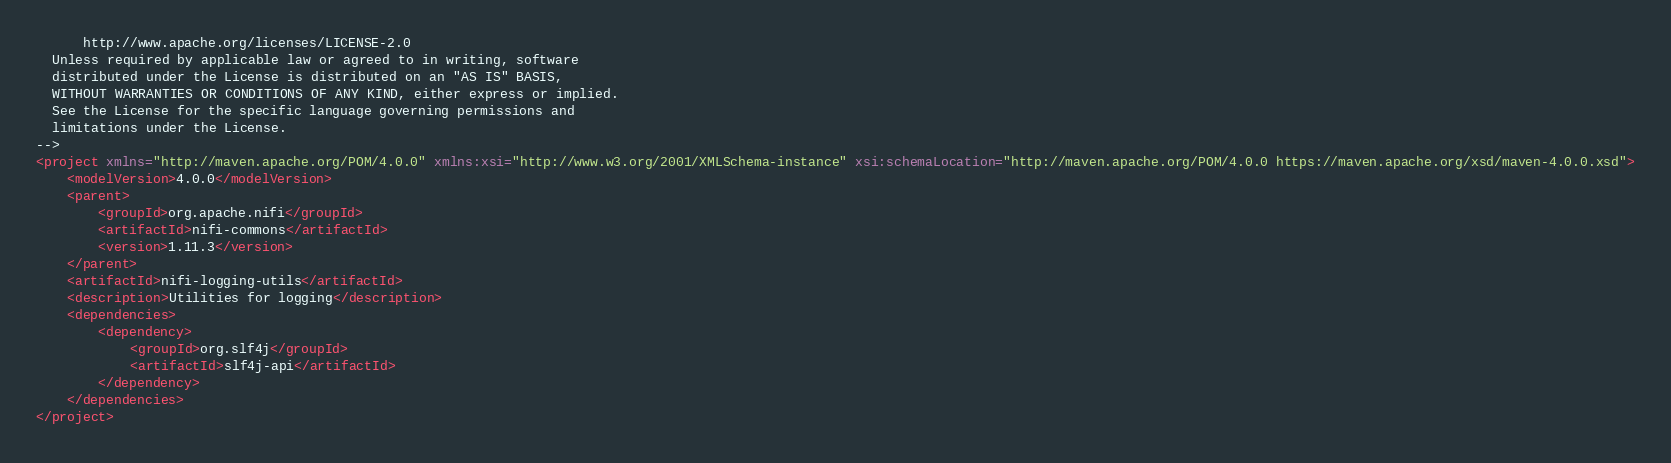<code> <loc_0><loc_0><loc_500><loc_500><_XML_>      http://www.apache.org/licenses/LICENSE-2.0
  Unless required by applicable law or agreed to in writing, software
  distributed under the License is distributed on an "AS IS" BASIS,
  WITHOUT WARRANTIES OR CONDITIONS OF ANY KIND, either express or implied.
  See the License for the specific language governing permissions and
  limitations under the License.
-->
<project xmlns="http://maven.apache.org/POM/4.0.0" xmlns:xsi="http://www.w3.org/2001/XMLSchema-instance" xsi:schemaLocation="http://maven.apache.org/POM/4.0.0 https://maven.apache.org/xsd/maven-4.0.0.xsd">
    <modelVersion>4.0.0</modelVersion>
    <parent>
        <groupId>org.apache.nifi</groupId>
        <artifactId>nifi-commons</artifactId>
        <version>1.11.3</version>
    </parent>
    <artifactId>nifi-logging-utils</artifactId>
    <description>Utilities for logging</description>
    <dependencies>
        <dependency>
            <groupId>org.slf4j</groupId>
            <artifactId>slf4j-api</artifactId>
        </dependency>
    </dependencies>
</project>
</code> 